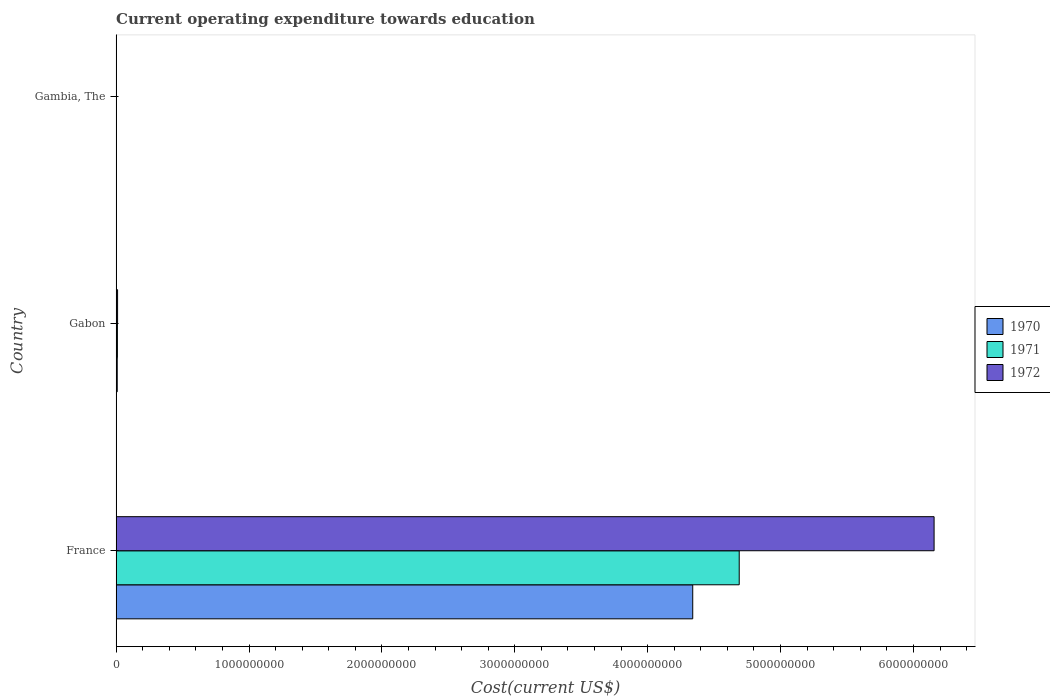How many different coloured bars are there?
Ensure brevity in your answer.  3. Are the number of bars per tick equal to the number of legend labels?
Ensure brevity in your answer.  Yes. How many bars are there on the 3rd tick from the top?
Your answer should be very brief. 3. How many bars are there on the 2nd tick from the bottom?
Offer a very short reply. 3. In how many cases, is the number of bars for a given country not equal to the number of legend labels?
Ensure brevity in your answer.  0. What is the expenditure towards education in 1970 in Gabon?
Ensure brevity in your answer.  8.29e+06. Across all countries, what is the maximum expenditure towards education in 1971?
Offer a terse response. 4.69e+09. Across all countries, what is the minimum expenditure towards education in 1972?
Give a very brief answer. 1.44e+06. In which country was the expenditure towards education in 1970 minimum?
Provide a succinct answer. Gambia, The. What is the total expenditure towards education in 1972 in the graph?
Ensure brevity in your answer.  6.17e+09. What is the difference between the expenditure towards education in 1972 in France and that in Gabon?
Ensure brevity in your answer.  6.14e+09. What is the difference between the expenditure towards education in 1970 in Gabon and the expenditure towards education in 1971 in France?
Provide a succinct answer. -4.68e+09. What is the average expenditure towards education in 1971 per country?
Provide a succinct answer. 1.57e+09. What is the difference between the expenditure towards education in 1971 and expenditure towards education in 1972 in Gambia, The?
Provide a short and direct response. -2.40e+05. In how many countries, is the expenditure towards education in 1970 greater than 2800000000 US$?
Make the answer very short. 1. What is the ratio of the expenditure towards education in 1972 in France to that in Gabon?
Provide a short and direct response. 567.19. Is the difference between the expenditure towards education in 1971 in France and Gambia, The greater than the difference between the expenditure towards education in 1972 in France and Gambia, The?
Ensure brevity in your answer.  No. What is the difference between the highest and the second highest expenditure towards education in 1970?
Your response must be concise. 4.33e+09. What is the difference between the highest and the lowest expenditure towards education in 1972?
Provide a succinct answer. 6.15e+09. In how many countries, is the expenditure towards education in 1972 greater than the average expenditure towards education in 1972 taken over all countries?
Offer a very short reply. 1. Is the sum of the expenditure towards education in 1972 in France and Gambia, The greater than the maximum expenditure towards education in 1970 across all countries?
Your answer should be compact. Yes. What does the 2nd bar from the top in Gambia, The represents?
Provide a succinct answer. 1971. What does the 1st bar from the bottom in France represents?
Give a very brief answer. 1970. Is it the case that in every country, the sum of the expenditure towards education in 1971 and expenditure towards education in 1972 is greater than the expenditure towards education in 1970?
Give a very brief answer. Yes. What is the difference between two consecutive major ticks on the X-axis?
Keep it short and to the point. 1.00e+09. Where does the legend appear in the graph?
Your answer should be compact. Center right. How many legend labels are there?
Give a very brief answer. 3. What is the title of the graph?
Keep it short and to the point. Current operating expenditure towards education. What is the label or title of the X-axis?
Your answer should be compact. Cost(current US$). What is the label or title of the Y-axis?
Give a very brief answer. Country. What is the Cost(current US$) of 1970 in France?
Give a very brief answer. 4.34e+09. What is the Cost(current US$) of 1971 in France?
Make the answer very short. 4.69e+09. What is the Cost(current US$) in 1972 in France?
Offer a very short reply. 6.16e+09. What is the Cost(current US$) in 1970 in Gabon?
Offer a terse response. 8.29e+06. What is the Cost(current US$) in 1971 in Gabon?
Your answer should be very brief. 9.66e+06. What is the Cost(current US$) in 1972 in Gabon?
Your response must be concise. 1.09e+07. What is the Cost(current US$) in 1970 in Gambia, The?
Provide a succinct answer. 1.15e+06. What is the Cost(current US$) of 1971 in Gambia, The?
Offer a terse response. 1.20e+06. What is the Cost(current US$) in 1972 in Gambia, The?
Your answer should be very brief. 1.44e+06. Across all countries, what is the maximum Cost(current US$) in 1970?
Offer a terse response. 4.34e+09. Across all countries, what is the maximum Cost(current US$) of 1971?
Provide a succinct answer. 4.69e+09. Across all countries, what is the maximum Cost(current US$) in 1972?
Give a very brief answer. 6.16e+09. Across all countries, what is the minimum Cost(current US$) in 1970?
Your answer should be very brief. 1.15e+06. Across all countries, what is the minimum Cost(current US$) of 1971?
Your response must be concise. 1.20e+06. Across all countries, what is the minimum Cost(current US$) of 1972?
Your response must be concise. 1.44e+06. What is the total Cost(current US$) in 1970 in the graph?
Ensure brevity in your answer.  4.35e+09. What is the total Cost(current US$) of 1971 in the graph?
Your answer should be compact. 4.70e+09. What is the total Cost(current US$) of 1972 in the graph?
Your response must be concise. 6.17e+09. What is the difference between the Cost(current US$) of 1970 in France and that in Gabon?
Keep it short and to the point. 4.33e+09. What is the difference between the Cost(current US$) in 1971 in France and that in Gabon?
Offer a terse response. 4.68e+09. What is the difference between the Cost(current US$) in 1972 in France and that in Gabon?
Your answer should be compact. 6.14e+09. What is the difference between the Cost(current US$) of 1970 in France and that in Gambia, The?
Your response must be concise. 4.34e+09. What is the difference between the Cost(current US$) of 1971 in France and that in Gambia, The?
Offer a terse response. 4.69e+09. What is the difference between the Cost(current US$) in 1972 in France and that in Gambia, The?
Your response must be concise. 6.15e+09. What is the difference between the Cost(current US$) in 1970 in Gabon and that in Gambia, The?
Your response must be concise. 7.14e+06. What is the difference between the Cost(current US$) in 1971 in Gabon and that in Gambia, The?
Ensure brevity in your answer.  8.46e+06. What is the difference between the Cost(current US$) in 1972 in Gabon and that in Gambia, The?
Your answer should be very brief. 9.41e+06. What is the difference between the Cost(current US$) in 1970 in France and the Cost(current US$) in 1971 in Gabon?
Offer a very short reply. 4.33e+09. What is the difference between the Cost(current US$) of 1970 in France and the Cost(current US$) of 1972 in Gabon?
Your response must be concise. 4.33e+09. What is the difference between the Cost(current US$) in 1971 in France and the Cost(current US$) in 1972 in Gabon?
Ensure brevity in your answer.  4.68e+09. What is the difference between the Cost(current US$) of 1970 in France and the Cost(current US$) of 1971 in Gambia, The?
Make the answer very short. 4.34e+09. What is the difference between the Cost(current US$) of 1970 in France and the Cost(current US$) of 1972 in Gambia, The?
Provide a short and direct response. 4.34e+09. What is the difference between the Cost(current US$) of 1971 in France and the Cost(current US$) of 1972 in Gambia, The?
Provide a succinct answer. 4.69e+09. What is the difference between the Cost(current US$) in 1970 in Gabon and the Cost(current US$) in 1971 in Gambia, The?
Make the answer very short. 7.10e+06. What is the difference between the Cost(current US$) in 1970 in Gabon and the Cost(current US$) in 1972 in Gambia, The?
Your answer should be compact. 6.85e+06. What is the difference between the Cost(current US$) in 1971 in Gabon and the Cost(current US$) in 1972 in Gambia, The?
Offer a very short reply. 8.22e+06. What is the average Cost(current US$) of 1970 per country?
Provide a short and direct response. 1.45e+09. What is the average Cost(current US$) of 1971 per country?
Offer a very short reply. 1.57e+09. What is the average Cost(current US$) of 1972 per country?
Keep it short and to the point. 2.06e+09. What is the difference between the Cost(current US$) in 1970 and Cost(current US$) in 1971 in France?
Keep it short and to the point. -3.50e+08. What is the difference between the Cost(current US$) of 1970 and Cost(current US$) of 1972 in France?
Ensure brevity in your answer.  -1.82e+09. What is the difference between the Cost(current US$) in 1971 and Cost(current US$) in 1972 in France?
Keep it short and to the point. -1.47e+09. What is the difference between the Cost(current US$) of 1970 and Cost(current US$) of 1971 in Gabon?
Ensure brevity in your answer.  -1.37e+06. What is the difference between the Cost(current US$) of 1970 and Cost(current US$) of 1972 in Gabon?
Give a very brief answer. -2.56e+06. What is the difference between the Cost(current US$) in 1971 and Cost(current US$) in 1972 in Gabon?
Make the answer very short. -1.19e+06. What is the difference between the Cost(current US$) of 1970 and Cost(current US$) of 1971 in Gambia, The?
Your answer should be very brief. -4.75e+04. What is the difference between the Cost(current US$) in 1970 and Cost(current US$) in 1972 in Gambia, The?
Give a very brief answer. -2.88e+05. What is the difference between the Cost(current US$) of 1971 and Cost(current US$) of 1972 in Gambia, The?
Offer a terse response. -2.40e+05. What is the ratio of the Cost(current US$) in 1970 in France to that in Gabon?
Your response must be concise. 523.2. What is the ratio of the Cost(current US$) of 1971 in France to that in Gabon?
Your answer should be compact. 485.47. What is the ratio of the Cost(current US$) in 1972 in France to that in Gabon?
Provide a short and direct response. 567.19. What is the ratio of the Cost(current US$) of 1970 in France to that in Gambia, The?
Offer a very short reply. 3771.39. What is the ratio of the Cost(current US$) in 1971 in France to that in Gambia, The?
Give a very brief answer. 3913.76. What is the ratio of the Cost(current US$) in 1972 in France to that in Gambia, The?
Your answer should be very brief. 4278.91. What is the ratio of the Cost(current US$) in 1970 in Gabon to that in Gambia, The?
Offer a very short reply. 7.21. What is the ratio of the Cost(current US$) of 1971 in Gabon to that in Gambia, The?
Provide a short and direct response. 8.06. What is the ratio of the Cost(current US$) of 1972 in Gabon to that in Gambia, The?
Offer a terse response. 7.54. What is the difference between the highest and the second highest Cost(current US$) of 1970?
Ensure brevity in your answer.  4.33e+09. What is the difference between the highest and the second highest Cost(current US$) of 1971?
Offer a very short reply. 4.68e+09. What is the difference between the highest and the second highest Cost(current US$) of 1972?
Provide a short and direct response. 6.14e+09. What is the difference between the highest and the lowest Cost(current US$) of 1970?
Provide a short and direct response. 4.34e+09. What is the difference between the highest and the lowest Cost(current US$) in 1971?
Give a very brief answer. 4.69e+09. What is the difference between the highest and the lowest Cost(current US$) in 1972?
Your answer should be very brief. 6.15e+09. 